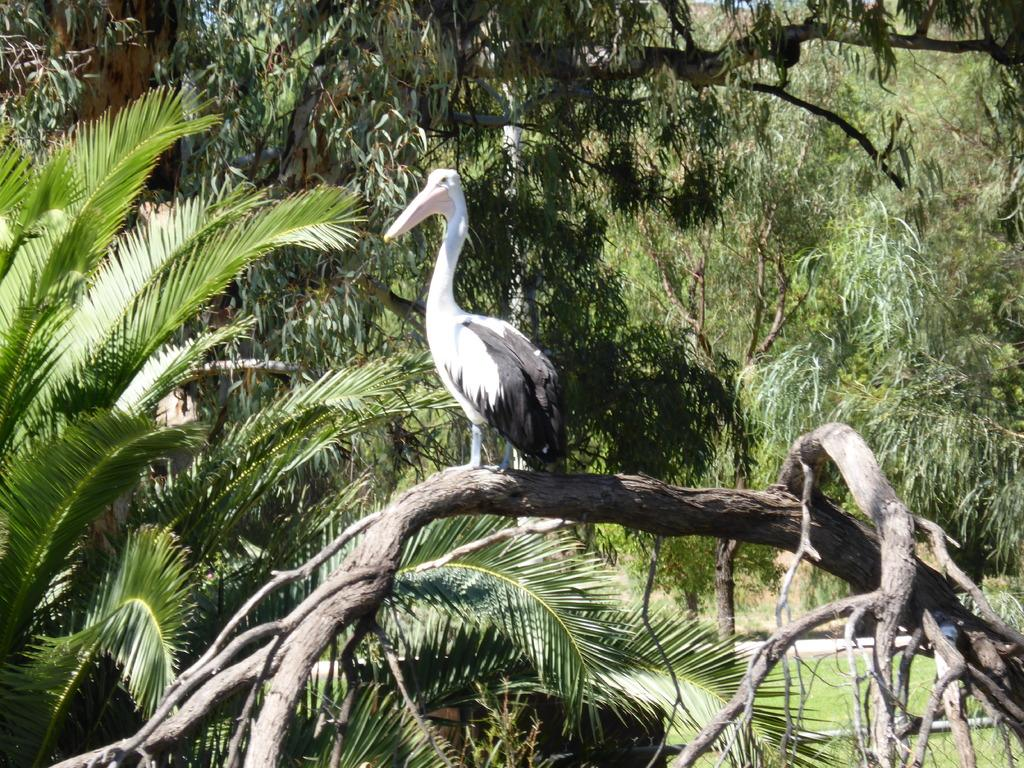What animal can be seen in the image? There is a bird on a branch in the image. What is the bird perched on? The bird is perched on a branch. What can be seen in the background of the image? There are trees in the background of the image. What type of meat is being cooked in the image? There is no meat or cooking activity present in the image; it features a bird on a branch with trees in the background. 